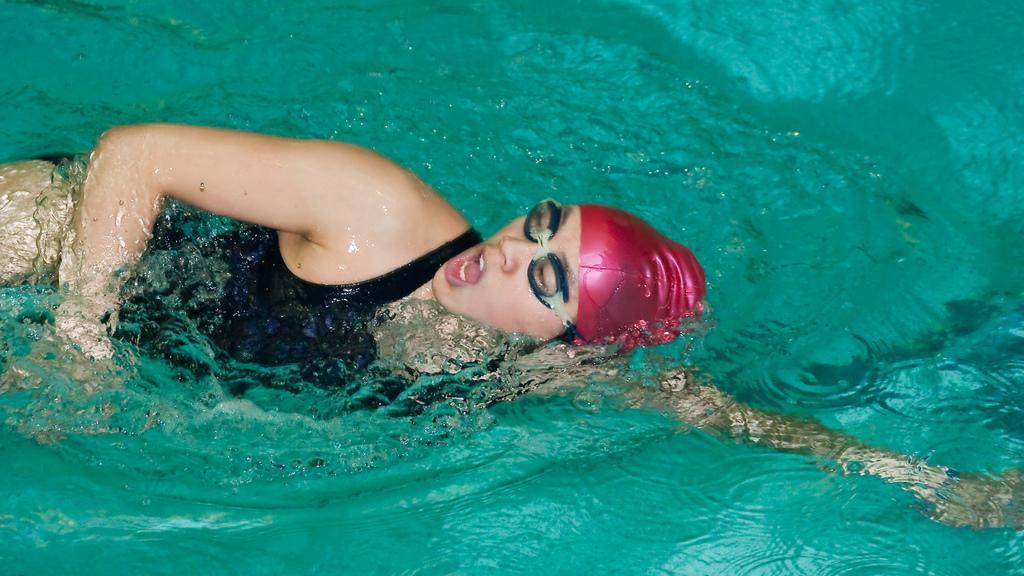Describe this image in one or two sentences. In this image there is a woman swimming in the water. She is wearing spectacles. There is a cap on her head. In the background there is the water. 